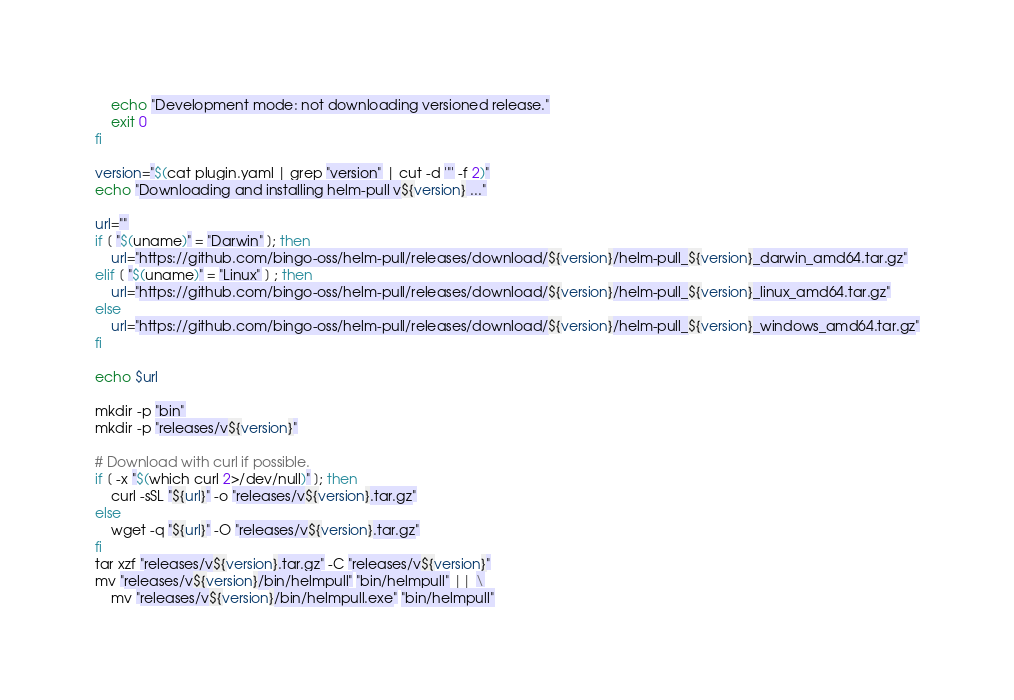<code> <loc_0><loc_0><loc_500><loc_500><_Bash_>    echo "Development mode: not downloading versioned release."
    exit 0
fi

version="$(cat plugin.yaml | grep "version" | cut -d '"' -f 2)"
echo "Downloading and installing helm-pull v${version} ..."

url=""
if [ "$(uname)" = "Darwin" ]; then
    url="https://github.com/bingo-oss/helm-pull/releases/download/${version}/helm-pull_${version}_darwin_amd64.tar.gz"
elif [ "$(uname)" = "Linux" ] ; then
    url="https://github.com/bingo-oss/helm-pull/releases/download/${version}/helm-pull_${version}_linux_amd64.tar.gz"
else
    url="https://github.com/bingo-oss/helm-pull/releases/download/${version}/helm-pull_${version}_windows_amd64.tar.gz"
fi

echo $url

mkdir -p "bin"
mkdir -p "releases/v${version}"

# Download with curl if possible.
if [ -x "$(which curl 2>/dev/null)" ]; then
    curl -sSL "${url}" -o "releases/v${version}.tar.gz"
else
    wget -q "${url}" -O "releases/v${version}.tar.gz"
fi
tar xzf "releases/v${version}.tar.gz" -C "releases/v${version}"
mv "releases/v${version}/bin/helmpull" "bin/helmpull" || \
    mv "releases/v${version}/bin/helmpull.exe" "bin/helmpull"</code> 